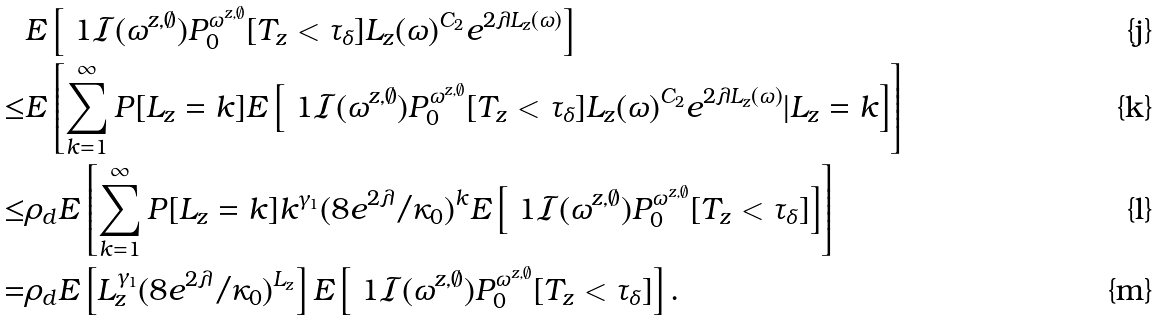<formula> <loc_0><loc_0><loc_500><loc_500>& { E } \left [ \ 1 { \mathcal { I } ( \omega ^ { z , \emptyset } ) } P _ { 0 } ^ { \omega ^ { z , \emptyset } } [ T _ { z } < \tau _ { \delta } ] L _ { z } ( \omega ) ^ { C _ { 2 } } e ^ { 2 \lambda L _ { z } ( \omega ) } \right ] \\ \leq & { E } \left [ \sum _ { k = 1 } ^ { \infty } { P } [ L _ { z } = k ] { E } \left [ \ 1 { \mathcal { I } ( \omega ^ { z , \emptyset } ) } P _ { 0 } ^ { \omega ^ { z , \emptyset } } [ T _ { z } < \tau _ { \delta } ] L _ { z } ( \omega ) ^ { C _ { 2 } } e ^ { 2 \lambda L _ { z } ( \omega ) } | L _ { z } = k \right ] \right ] \\ \leq & \rho _ { d } { E } \left [ \sum _ { k = 1 } ^ { \infty } { P } [ L _ { z } = k ] k ^ { \gamma _ { 1 } } ( 8 e ^ { 2 \lambda } / \kappa _ { 0 } ) ^ { k } { E } \left [ \ 1 { \mathcal { I } ( \omega ^ { z , \emptyset } ) } P _ { 0 } ^ { \omega ^ { z , \emptyset } } [ T _ { z } < \tau _ { \delta } ] \right ] \right ] \\ = & \rho _ { d } { E } \left [ L _ { z } ^ { \gamma _ { 1 } } ( 8 e ^ { 2 \lambda } / \kappa _ { 0 } ) ^ { L _ { z } } \right ] { E } \left [ \ 1 { \mathcal { I } ( \omega ^ { z , \emptyset } ) } P _ { 0 } ^ { \omega ^ { z , \emptyset } } [ T _ { z } < \tau _ { \delta } ] \right ] .</formula> 